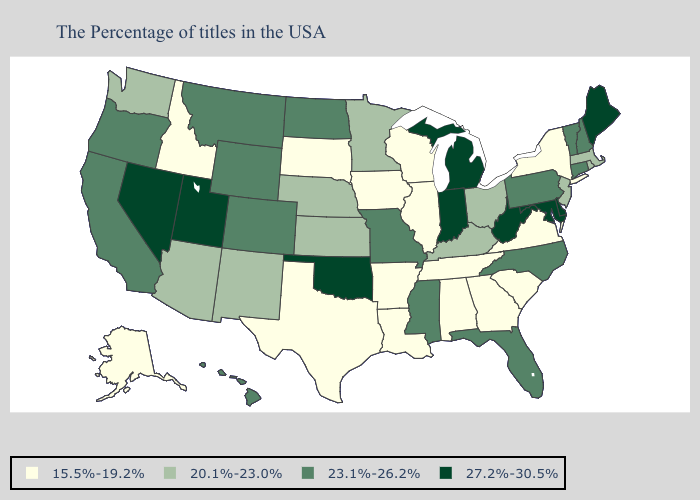What is the value of Colorado?
Write a very short answer. 23.1%-26.2%. Does New York have the same value as Nevada?
Short answer required. No. What is the lowest value in the USA?
Keep it brief. 15.5%-19.2%. What is the lowest value in the USA?
Write a very short answer. 15.5%-19.2%. Does Vermont have the lowest value in the Northeast?
Keep it brief. No. What is the highest value in the USA?
Quick response, please. 27.2%-30.5%. Does Ohio have a higher value than Nebraska?
Answer briefly. No. Does Virginia have the same value as South Dakota?
Give a very brief answer. Yes. What is the lowest value in states that border Kansas?
Give a very brief answer. 20.1%-23.0%. Name the states that have a value in the range 15.5%-19.2%?
Answer briefly. New York, Virginia, South Carolina, Georgia, Alabama, Tennessee, Wisconsin, Illinois, Louisiana, Arkansas, Iowa, Texas, South Dakota, Idaho, Alaska. What is the value of Nebraska?
Short answer required. 20.1%-23.0%. What is the value of Washington?
Be succinct. 20.1%-23.0%. What is the value of Hawaii?
Be succinct. 23.1%-26.2%. What is the value of Alabama?
Be succinct. 15.5%-19.2%. Name the states that have a value in the range 20.1%-23.0%?
Give a very brief answer. Massachusetts, Rhode Island, New Jersey, Ohio, Kentucky, Minnesota, Kansas, Nebraska, New Mexico, Arizona, Washington. 